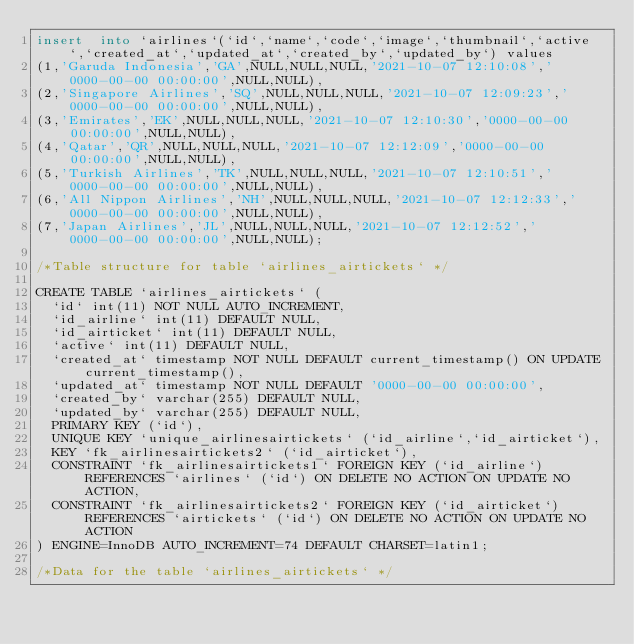<code> <loc_0><loc_0><loc_500><loc_500><_SQL_>insert  into `airlines`(`id`,`name`,`code`,`image`,`thumbnail`,`active`,`created_at`,`updated_at`,`created_by`,`updated_by`) values 
(1,'Garuda Indonesia','GA',NULL,NULL,NULL,'2021-10-07 12:10:08','0000-00-00 00:00:00',NULL,NULL),
(2,'Singapore Airlines','SQ',NULL,NULL,NULL,'2021-10-07 12:09:23','0000-00-00 00:00:00',NULL,NULL),
(3,'Emirates','EK',NULL,NULL,NULL,'2021-10-07 12:10:30','0000-00-00 00:00:00',NULL,NULL),
(4,'Qatar','QR',NULL,NULL,NULL,'2021-10-07 12:12:09','0000-00-00 00:00:00',NULL,NULL),
(5,'Turkish Airlines','TK',NULL,NULL,NULL,'2021-10-07 12:10:51','0000-00-00 00:00:00',NULL,NULL),
(6,'All Nippon Airlines','NH',NULL,NULL,NULL,'2021-10-07 12:12:33','0000-00-00 00:00:00',NULL,NULL),
(7,'Japan Airlines','JL',NULL,NULL,NULL,'2021-10-07 12:12:52','0000-00-00 00:00:00',NULL,NULL);

/*Table structure for table `airlines_airtickets` */

CREATE TABLE `airlines_airtickets` (
  `id` int(11) NOT NULL AUTO_INCREMENT,
  `id_airline` int(11) DEFAULT NULL,
  `id_airticket` int(11) DEFAULT NULL,
  `active` int(11) DEFAULT NULL,
  `created_at` timestamp NOT NULL DEFAULT current_timestamp() ON UPDATE current_timestamp(),
  `updated_at` timestamp NOT NULL DEFAULT '0000-00-00 00:00:00',
  `created_by` varchar(255) DEFAULT NULL,
  `updated_by` varchar(255) DEFAULT NULL,
  PRIMARY KEY (`id`),
  UNIQUE KEY `unique_airlinesairtickets` (`id_airline`,`id_airticket`),
  KEY `fk_airlinesairtickets2` (`id_airticket`),
  CONSTRAINT `fk_airlinesairtickets1` FOREIGN KEY (`id_airline`) REFERENCES `airlines` (`id`) ON DELETE NO ACTION ON UPDATE NO ACTION,
  CONSTRAINT `fk_airlinesairtickets2` FOREIGN KEY (`id_airticket`) REFERENCES `airtickets` (`id`) ON DELETE NO ACTION ON UPDATE NO ACTION
) ENGINE=InnoDB AUTO_INCREMENT=74 DEFAULT CHARSET=latin1;

/*Data for the table `airlines_airtickets` */
</code> 